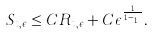Convert formula to latex. <formula><loc_0><loc_0><loc_500><loc_500>S _ { t , \epsilon } \leq C R _ { t , \epsilon } + C \epsilon ^ { \frac { 1 } { 1 - \theta _ { 1 } } } .</formula> 